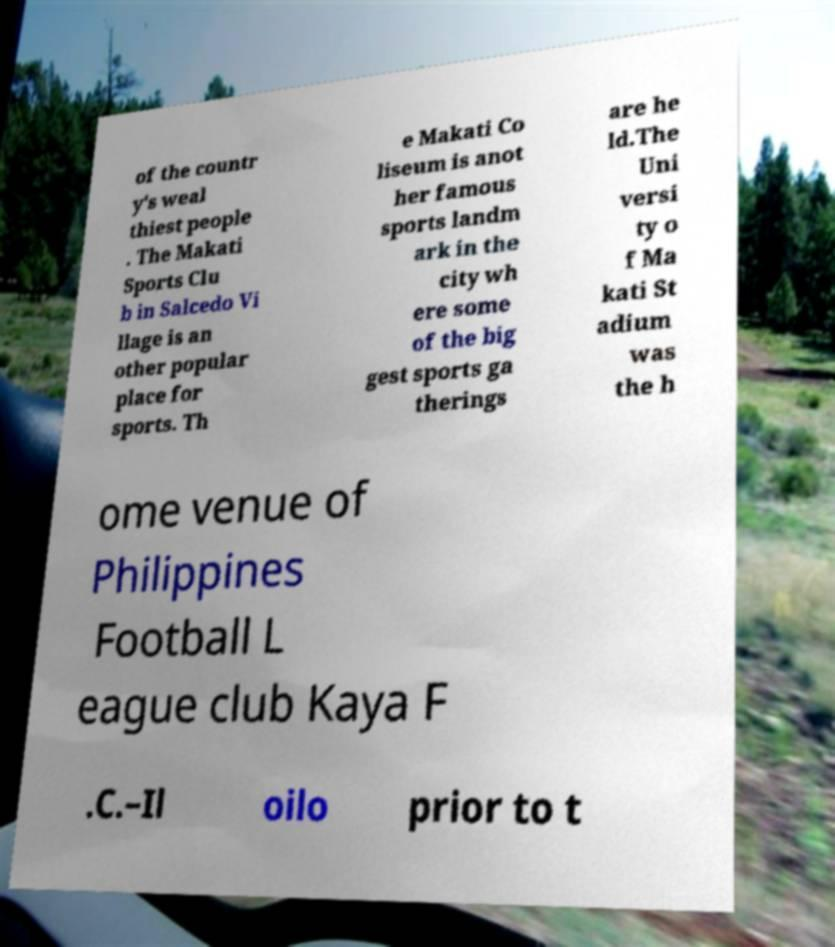Could you extract and type out the text from this image? of the countr y's weal thiest people . The Makati Sports Clu b in Salcedo Vi llage is an other popular place for sports. Th e Makati Co liseum is anot her famous sports landm ark in the city wh ere some of the big gest sports ga therings are he ld.The Uni versi ty o f Ma kati St adium was the h ome venue of Philippines Football L eague club Kaya F .C.–Il oilo prior to t 